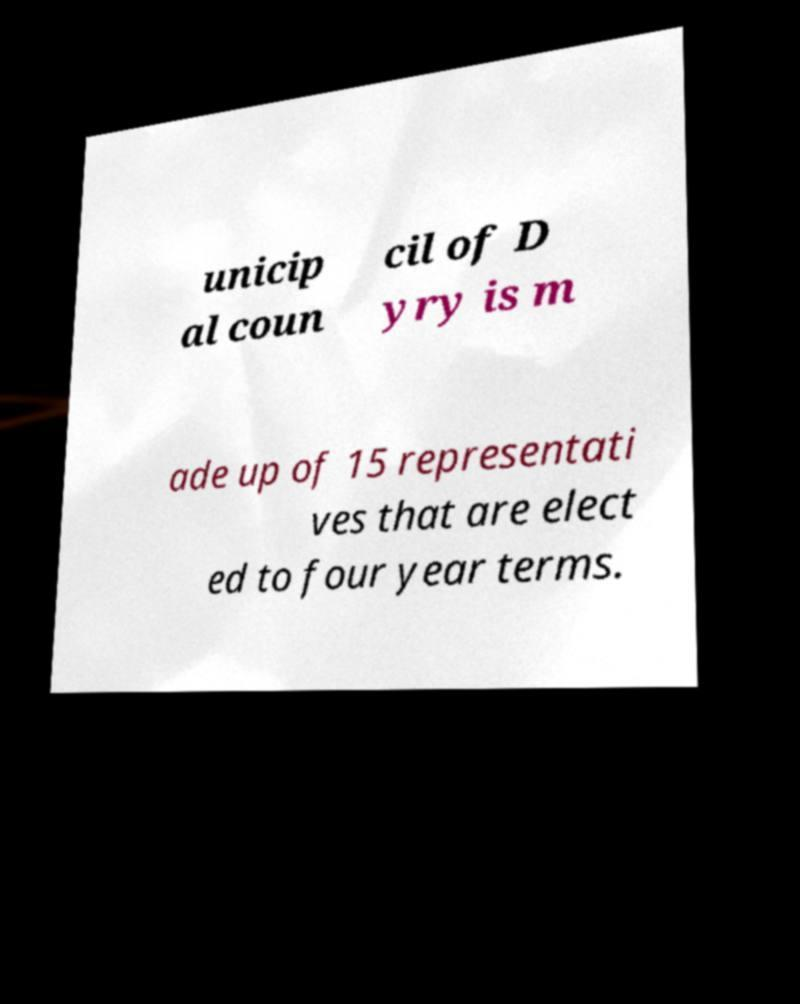Could you assist in decoding the text presented in this image and type it out clearly? unicip al coun cil of D yry is m ade up of 15 representati ves that are elect ed to four year terms. 